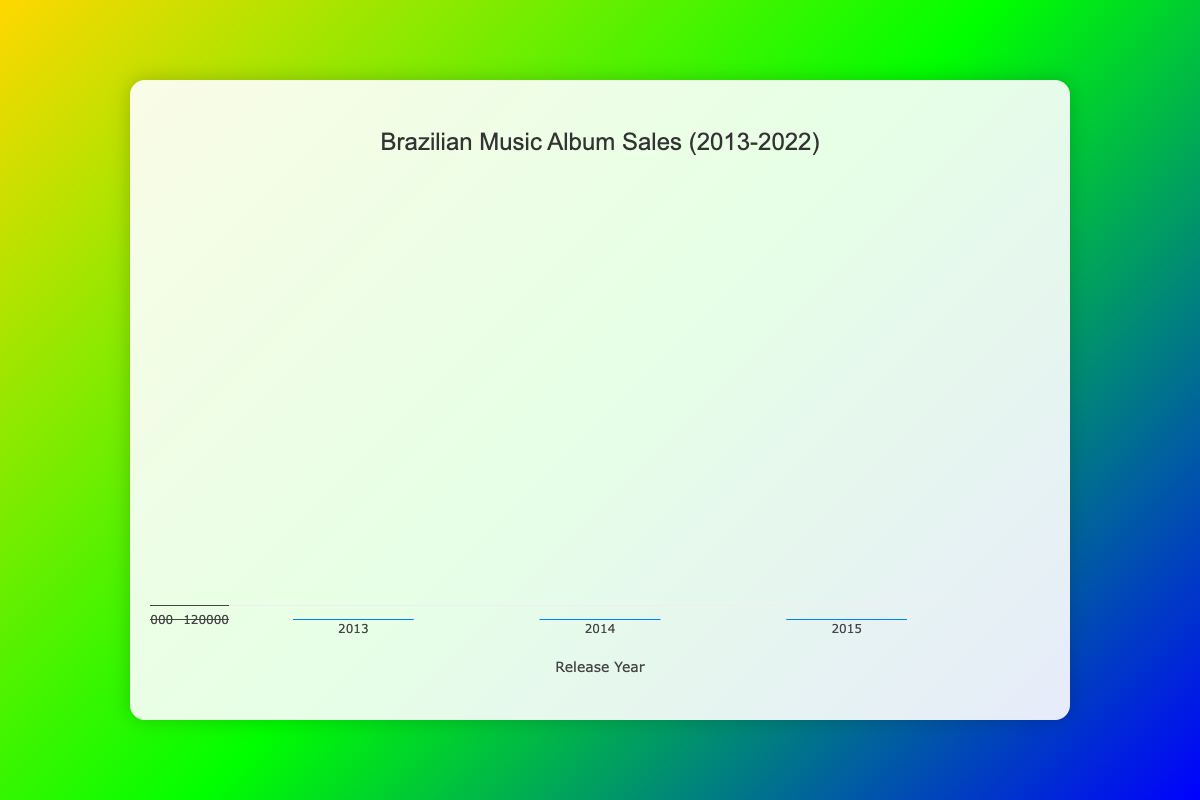What is the title of the box plot? The title of the box plot is usually located at the top of the chart. It summarizes what the chart is about.
Answer: Brazilian Music Album Sales (2013-2022) What does the y-axis represent? The y-axis typically indicates the measured values in the dataset. In this box plot, it represents the number of album sales units.
Answer: Sales Units Which year had the highest median album sales? To determine this, look at the middle line (median) of each box from different years. The year with the highest middle line is the answer.
Answer: 2019 How does the range of album sales in 2019 compare to 2013? To compare the ranges, observe the minimum and maximum values (the shadows or whiskers) for both years. The range is the difference between the maximum and minimum.
Answer: 2019 has a larger range than 2013 What is the interquartile range (IQR) for album sales in 2018? The Interquartile Range (IQR) is found by subtracting the value at the 25th percentile (bottom of the box) from the value at the 75th percentile (top of the box).
Answer: 45,000 units Which year shows the most variability in album sales? Variability can be assessed by looking at the height of the box; a taller box indicates more variability. The whiskers also contribute to understanding variability.
Answer: 2014 How many years have an artist with album sales close to 90,000? Look at the plot and count the years where one of the distribution points or the box edges are around the 90,000 mark.
Answer: 5 years (2015, 2017, 2018, 2019, 2021) What is the lowest album sales value recorded in 2022? The lowest value is typically the bottom whisker or the bottom dataset point in the box plot for the year 2022.
Answer: 60,000 units Which year had the highest album sales outlier and what was its value? An outlier in a box plot is generally a point distinct from the majority of the data. It would be a lone point above the whiskers.
Answer: 2019, 160,000 units Does any artist have multiple top-selling albums recorded within this data? This can be determined by observing multiple entries of the same artist over different years within the dataset provided.
Answer: Yes, Anitta (2013 and 2018) 